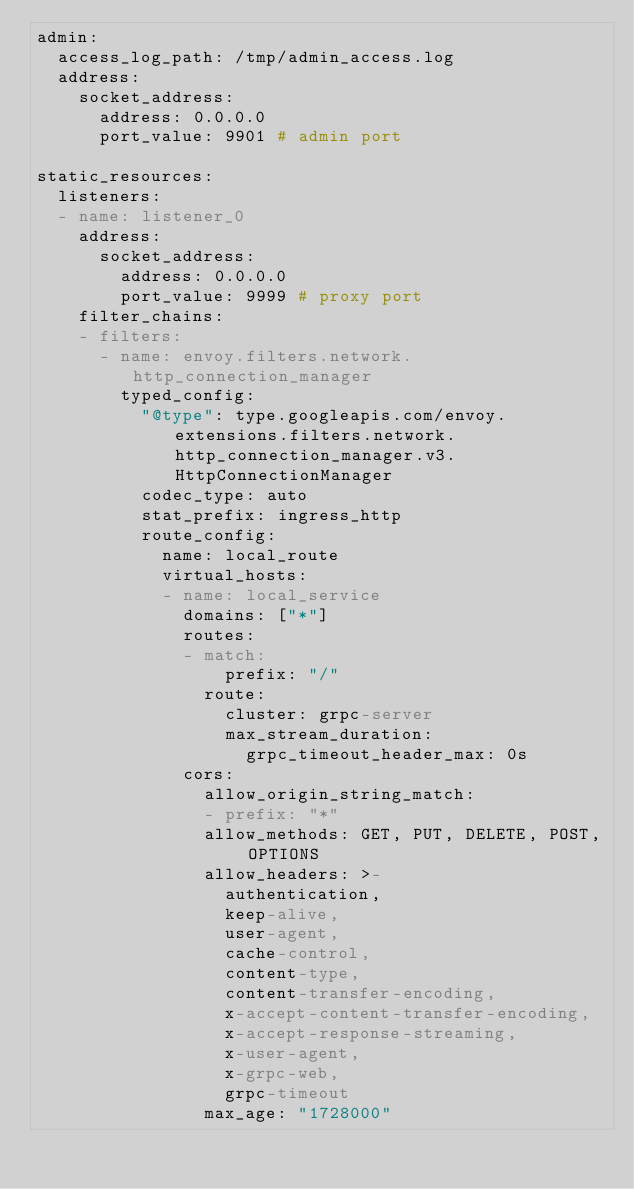Convert code to text. <code><loc_0><loc_0><loc_500><loc_500><_YAML_>admin:
  access_log_path: /tmp/admin_access.log
  address:
    socket_address:
      address: 0.0.0.0
      port_value: 9901 # admin port

static_resources:
  listeners:
  - name: listener_0
    address:
      socket_address:
        address: 0.0.0.0
        port_value: 9999 # proxy port
    filter_chains:
    - filters:
      - name: envoy.filters.network.http_connection_manager
        typed_config:
          "@type": type.googleapis.com/envoy.extensions.filters.network.http_connection_manager.v3.HttpConnectionManager
          codec_type: auto
          stat_prefix: ingress_http
          route_config:
            name: local_route
            virtual_hosts:
            - name: local_service
              domains: ["*"]
              routes:
              - match:
                  prefix: "/"
                route:
                  cluster: grpc-server
                  max_stream_duration:
                    grpc_timeout_header_max: 0s
              cors:
                allow_origin_string_match:
                - prefix: "*"
                allow_methods: GET, PUT, DELETE, POST, OPTIONS
                allow_headers: >-
                  authentication,
                  keep-alive,
                  user-agent,
                  cache-control,
                  content-type,
                  content-transfer-encoding,
                  x-accept-content-transfer-encoding,
                  x-accept-response-streaming,
                  x-user-agent,
                  x-grpc-web,
                  grpc-timeout
                max_age: "1728000"</code> 